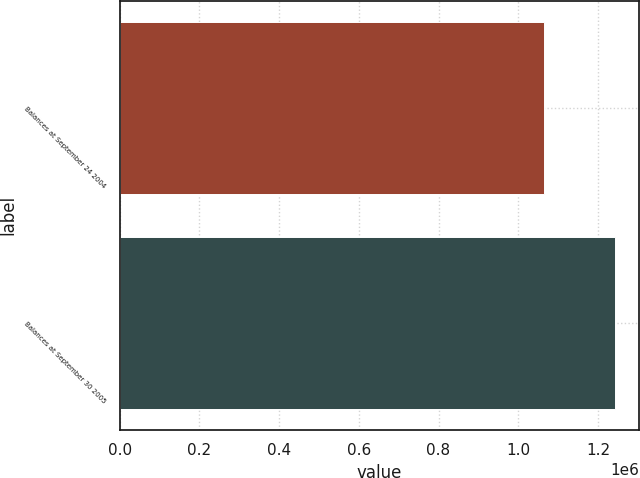Convert chart. <chart><loc_0><loc_0><loc_500><loc_500><bar_chart><fcel>Balances at September 24 2004<fcel>Balances at September 30 2005<nl><fcel>1.06521e+06<fcel>1.24182e+06<nl></chart> 